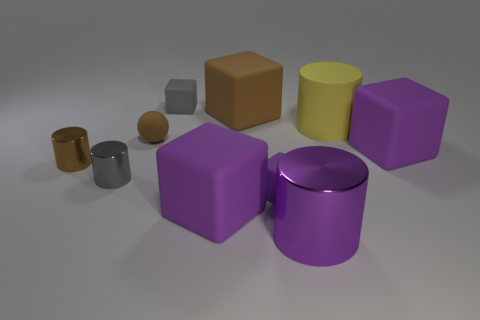Are the sphere and the small brown cylinder made of the same material?
Offer a terse response. No. There is a metallic cylinder that is the same size as the brown block; what is its color?
Your answer should be compact. Purple. The thing that is right of the gray cylinder and to the left of the gray rubber block is what color?
Give a very brief answer. Brown. The cylinder that is the same color as the matte sphere is what size?
Offer a very short reply. Small. What is the shape of the big matte thing that is the same color as the small rubber sphere?
Give a very brief answer. Cube. What size is the brown thing behind the tiny matte thing to the left of the gray object behind the yellow rubber cylinder?
Ensure brevity in your answer.  Large. What is the big brown cube made of?
Your answer should be very brief. Rubber. Is the material of the small brown ball the same as the small gray thing that is on the right side of the gray cylinder?
Your answer should be very brief. Yes. Are there any other things that have the same color as the large metallic object?
Ensure brevity in your answer.  Yes. Are there any big brown objects that are in front of the gray metallic cylinder that is in front of the rubber ball left of the big yellow rubber cylinder?
Keep it short and to the point. No. 